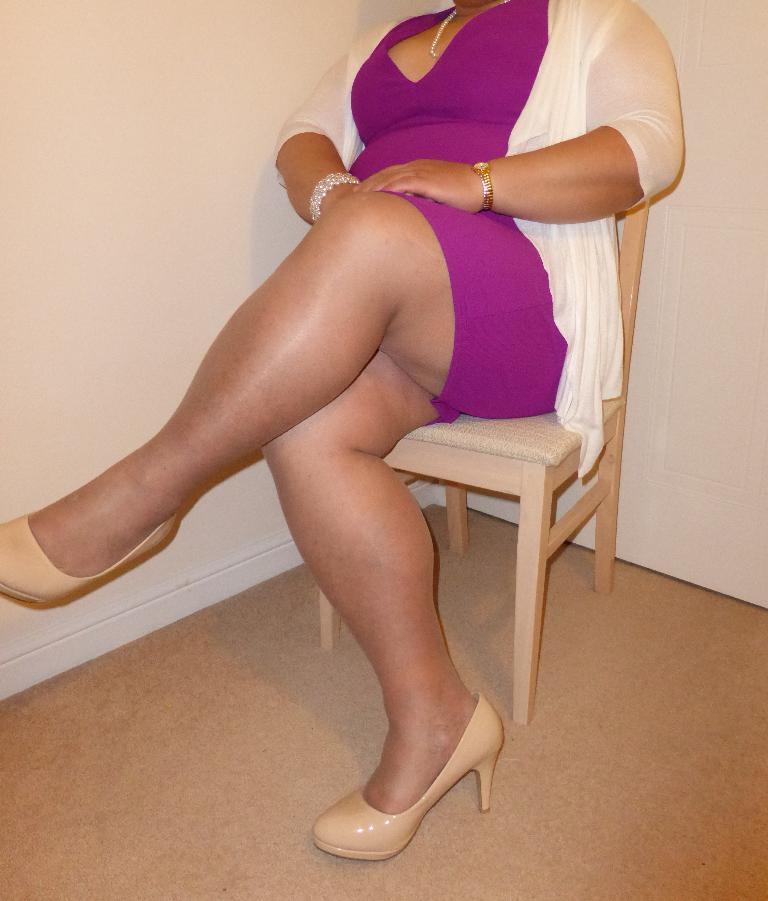How would you summarize this image in a sentence or two? In this image there is a woman sitting on the chair. In the background there is a wall. 